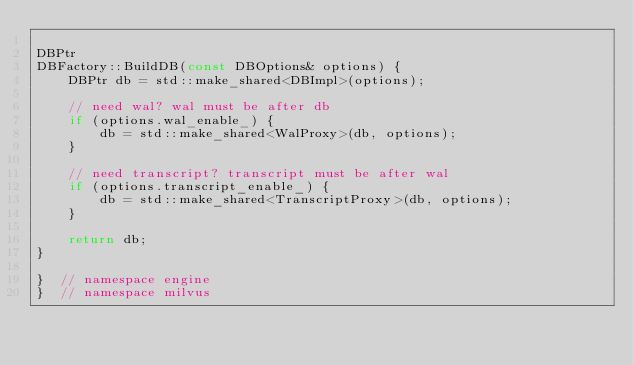<code> <loc_0><loc_0><loc_500><loc_500><_C++_>
DBPtr
DBFactory::BuildDB(const DBOptions& options) {
    DBPtr db = std::make_shared<DBImpl>(options);

    // need wal? wal must be after db
    if (options.wal_enable_) {
        db = std::make_shared<WalProxy>(db, options);
    }

    // need transcript? transcript must be after wal
    if (options.transcript_enable_) {
        db = std::make_shared<TranscriptProxy>(db, options);
    }

    return db;
}

}  // namespace engine
}  // namespace milvus
</code> 